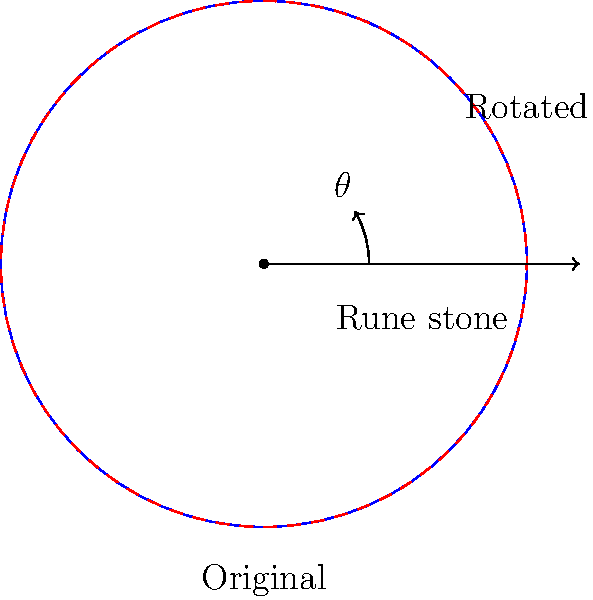As a nature photographer, you've captured a landscape image that needs to be aligned with a nearby Viking rune stone for historical context. The rune stone is oriented 30° clockwise from the horizontal axis in your photograph. What transformation should be applied to rotate the landscape image to align with the rune stone's orientation? To align the landscape image with the rune stone's orientation, we need to rotate the image clockwise by the same angle as the rune stone's orientation. Here's the step-by-step process:

1. Identify the angle of rotation: The rune stone is oriented 30° clockwise from the horizontal axis.

2. Determine the direction of rotation: Since we want to align the image with the rune stone, we need to rotate the image in the same direction (clockwise).

3. Apply the rotation transformation: In transformational geometry, a clockwise rotation by $\theta$ degrees around the origin is represented by the matrix:

   $$\begin{bmatrix} 
   \cos\theta & -\sin\theta \\
   \sin\theta & \cos\theta
   \end{bmatrix}$$

   In this case, $\theta = 30°$.

4. The transformation can be expressed as:
   
   $$R_{30°} = \begin{bmatrix} 
   \cos30° & -\sin30° \\
   \sin30° & \cos30°
   \end{bmatrix}$$

Therefore, to align the landscape image with the rune stone's orientation, we need to apply a clockwise rotation of 30° to the image.
Answer: Rotate 30° clockwise 